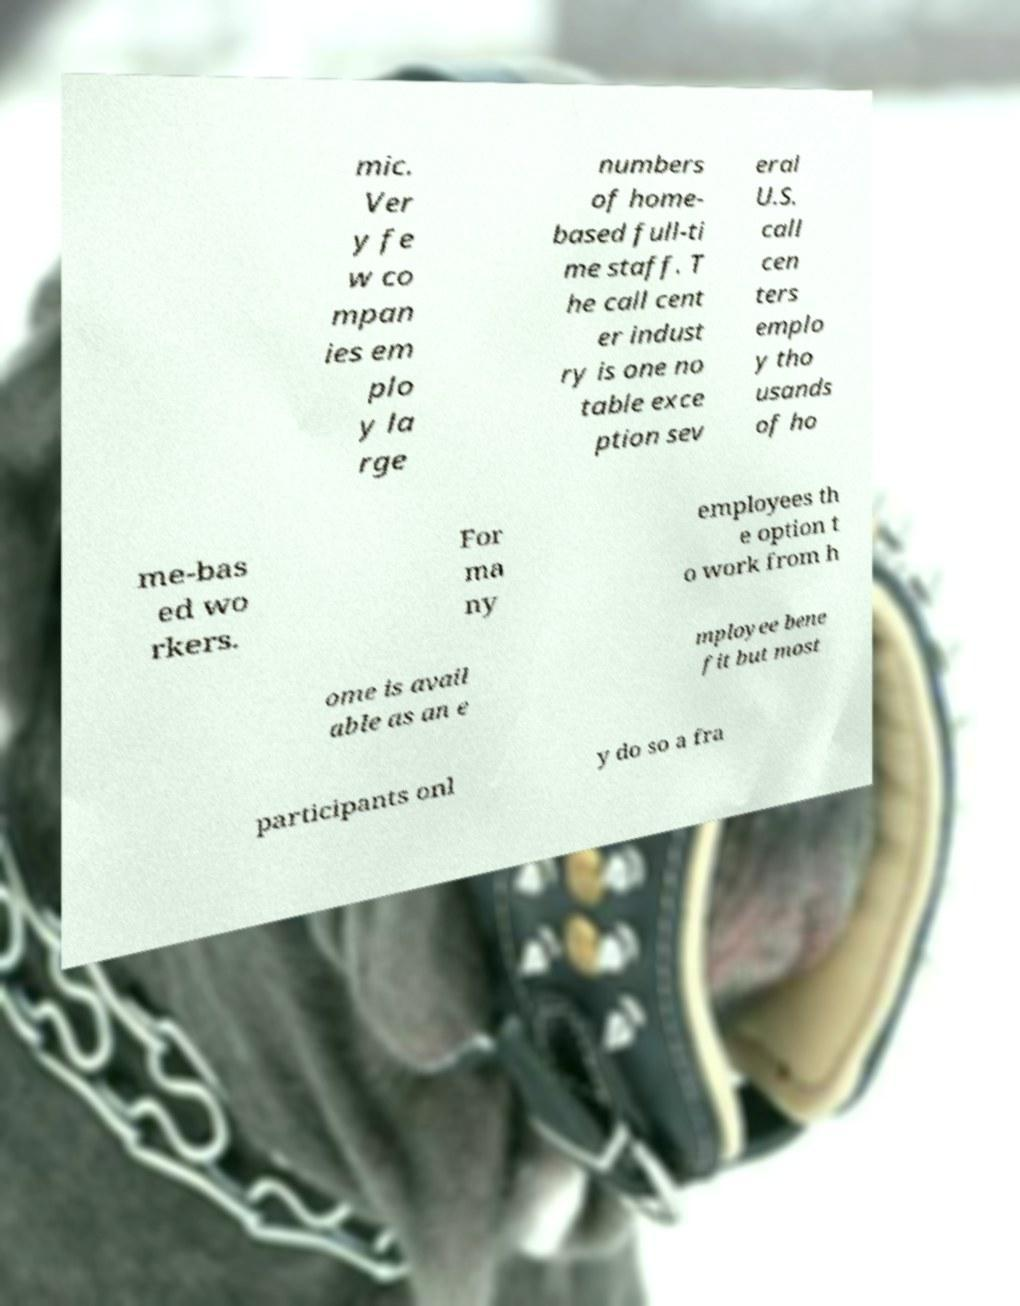Please identify and transcribe the text found in this image. mic. Ver y fe w co mpan ies em plo y la rge numbers of home- based full-ti me staff. T he call cent er indust ry is one no table exce ption sev eral U.S. call cen ters emplo y tho usands of ho me-bas ed wo rkers. For ma ny employees th e option t o work from h ome is avail able as an e mployee bene fit but most participants onl y do so a fra 